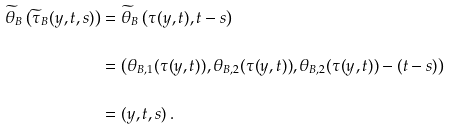Convert formula to latex. <formula><loc_0><loc_0><loc_500><loc_500>\widetilde { \theta } _ { B } \left ( \widetilde { \tau } _ { B } ( y , t , s ) \right ) & = \widetilde { \theta } _ { B } \left ( \tau ( y , t ) , t - s \right ) \\ & = \left ( \theta _ { B , 1 } ( \tau ( y , t ) ) , \theta _ { B , 2 } ( \tau ( y , t ) ) , \theta _ { B , 2 } ( \tau ( y , t ) ) - ( t - s ) \right ) \\ & = ( y , t , s ) \, .</formula> 